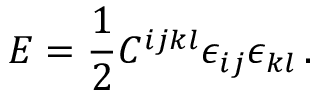Convert formula to latex. <formula><loc_0><loc_0><loc_500><loc_500>E = \frac { 1 } { 2 } C ^ { i j k l } \epsilon _ { i j } \epsilon _ { k l } \, .</formula> 